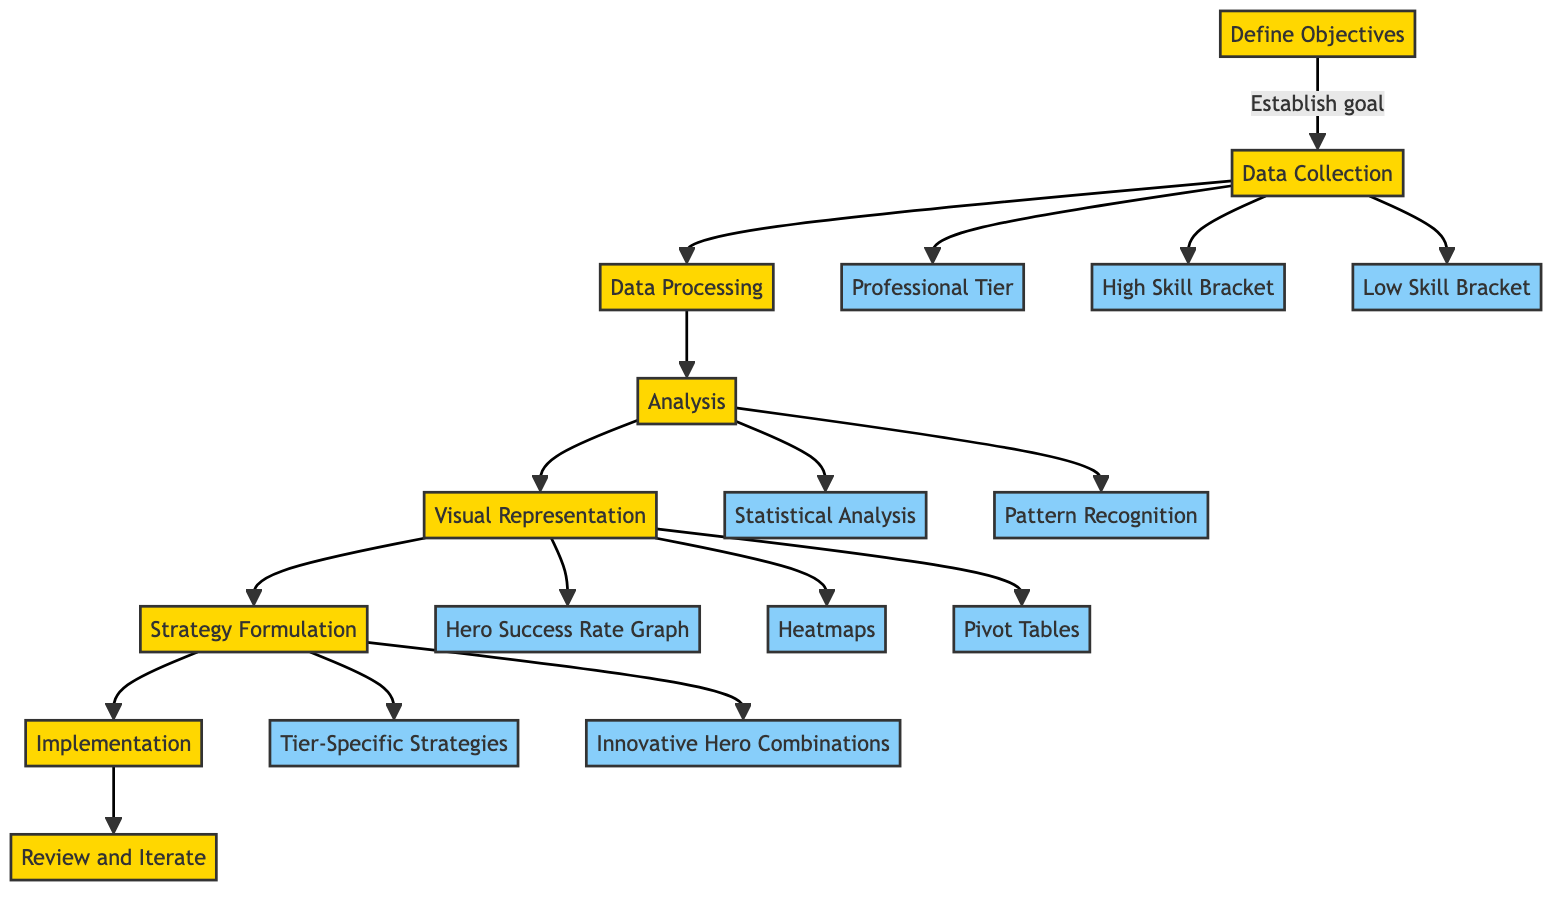What is the first step in the process? The first step is "Define Objectives," which establishes the goal of the analysis.
Answer: Define Objectives How many substeps are under Data Collection? There are three substeps under Data Collection: Professional Tier, High Skill Bracket, and Low Skill Bracket.
Answer: Three What follows after Data Processing? After Data Processing, the next step is Analysis.
Answer: Analysis Which step involves visual representation of the findings? The step that involves visual representation is "Visual Representation."
Answer: Visual Representation What are the two substeps under Strategy Formulation? The two substeps are "Tier-Specific Strategies" and "Innovative Hero Combinations."
Answer: Tier-Specific Strategies and Innovative Hero Combinations Which substep focuses on evaluating pick success rate differences? The substep that focuses on this is "Statistical Analysis."
Answer: Statistical Analysis What last step is important for continual improvement? The last step is "Review and Iterate," which emphasizes ongoing analysis and refinement of strategies.
Answer: Review and Iterate How many main steps are there in total? There are eight main steps in total in the clinical pathway.
Answer: Eight What type of analysis identifies patterns and correlations in hero success? The type of analysis is "Pattern Recognition."
Answer: Pattern Recognition 